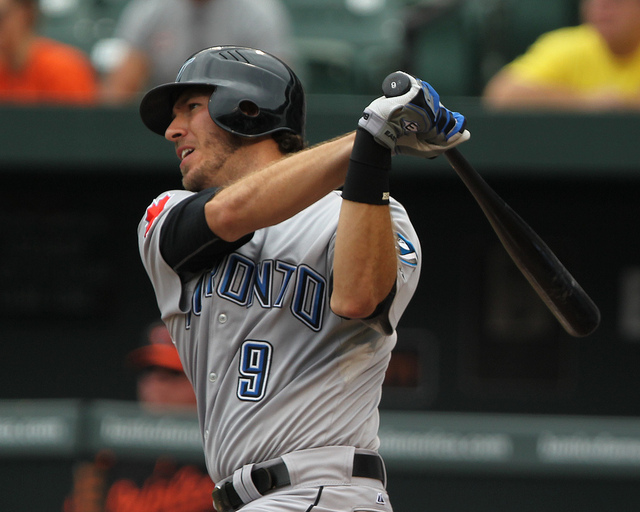Please extract the text content from this image. 9 TO 